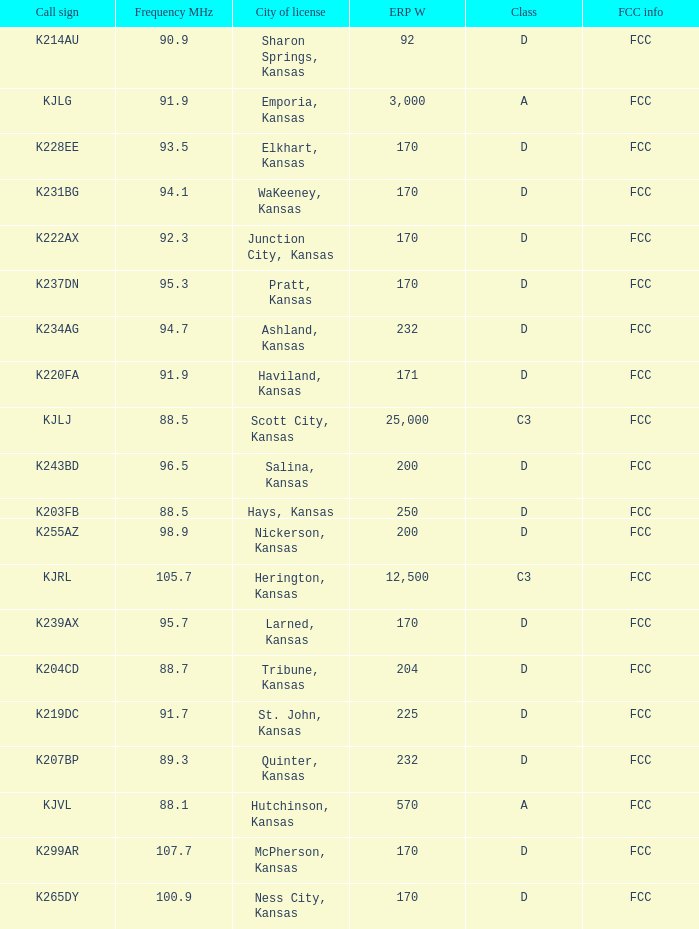Class of d, and a Frequency MHz smaller than 107.7, and a ERP W smaller than 232 has what call sign? K255AZ, K228EE, K220FA, K265DY, K237DN, K214AU, K222AX, K239AX, K243BD, K219DC, K204CD, K231BG. 